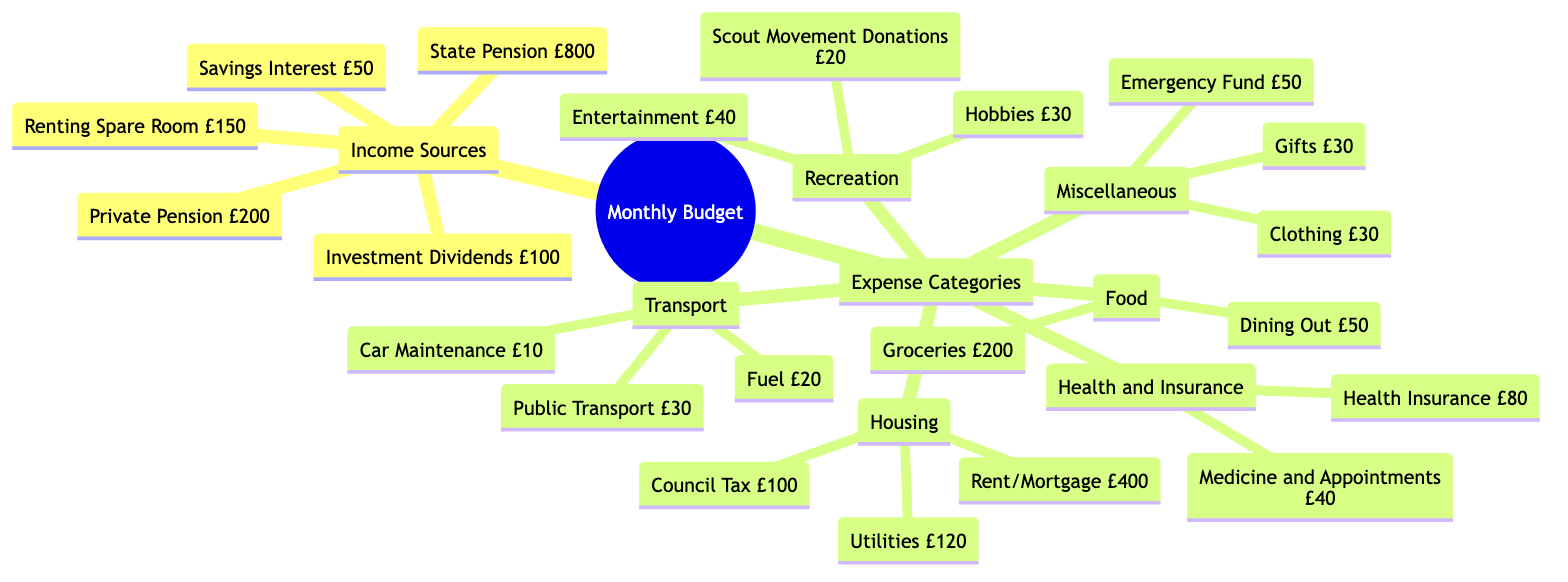what is the total income from all sources? To find the total income, we need to sum the values of all income sources listed: State Pension (£800) + Private Pension (£200) + Savings Interest (£50) + Investment Dividends (£100) + Renting Spare Room (£150) = £1300.
Answer: £1300 what is the expense for groceries? The diagram lists the expense for groceries explicitly as £200. There is no need for calculation, as it is directly provided.
Answer: £200 how much is spent on health insurance? The diagram shows the expense on health insurance clearly as £80. This information is taken directly from the expense categories without any need for further calculation.
Answer: £80 which expense category has the highest total amount? To determine which expense category has the highest total amount, we sum the expenses for each category: Housing (£620), Food (£250), Health and Insurance (£120), Transport (£60), Recreation (£90), Miscellaneous (£140). Therefore, Housing has the highest total of £620.
Answer: Housing what is the total amount spent on recreation? To find the total amount spent on recreation, we add the values under that category: Scout Movement Donations (£20) + Entertainment (£40) + Hobbies (£30) = £90. This calculation gives us the total expense for recreation.
Answer: £90 how many income sources are listed in the diagram? The diagram has a total of five different income sources: State Pension, Private Pension, Savings Interest, Investment Dividends, and Renting Spare Room. Counting these gives us five income sources in total.
Answer: 5 what is the combined cost of all miscellaneous expenses? The miscellaneous expenses listed are Clothing (£30), Gifts (£30), and Emergency Fund (£50). Adding these values together gives: £30 + £30 + £50 = £110. Thus, the total combined cost of all miscellaneous expenses is £110.
Answer: £110 which expense category does not include car maintenance? By reviewing the expense categories, we see Transport has car maintenance listed. Food and Miscellaneous do not have any car maintenance expenses included. Therefore, the categories without car maintenance are Food and Miscellaneous.
Answer: Food and Miscellaneous how much does the individual receive from renting a spare room? The diagram explicitly states that the income from renting a spare room is £150. There is no additional calculation necessary since the amount is directly provided.
Answer: £150 